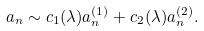Convert formula to latex. <formula><loc_0><loc_0><loc_500><loc_500>a _ { n } \sim c _ { 1 } ( \lambda ) a _ { n } ^ { ( 1 ) } + c _ { 2 } ( \lambda ) a _ { n } ^ { ( 2 ) } .</formula> 